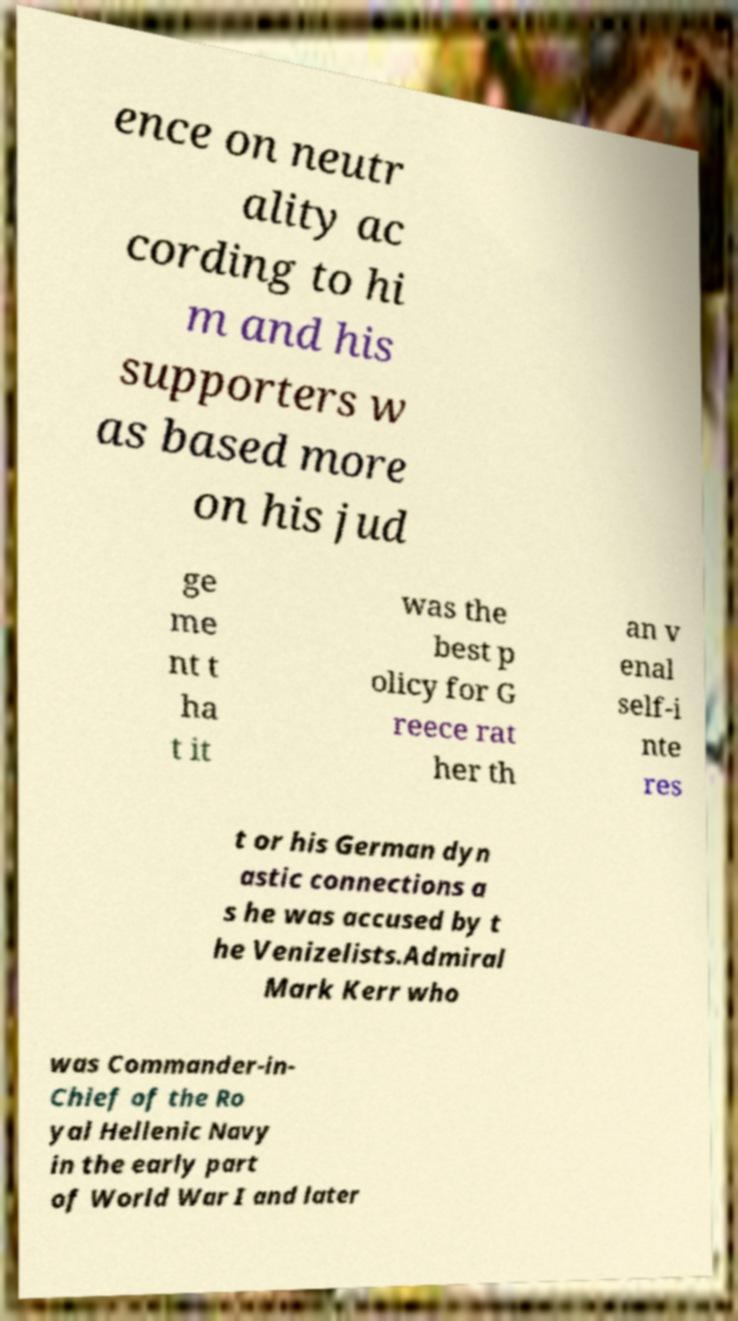Can you read and provide the text displayed in the image?This photo seems to have some interesting text. Can you extract and type it out for me? ence on neutr ality ac cording to hi m and his supporters w as based more on his jud ge me nt t ha t it was the best p olicy for G reece rat her th an v enal self-i nte res t or his German dyn astic connections a s he was accused by t he Venizelists.Admiral Mark Kerr who was Commander-in- Chief of the Ro yal Hellenic Navy in the early part of World War I and later 